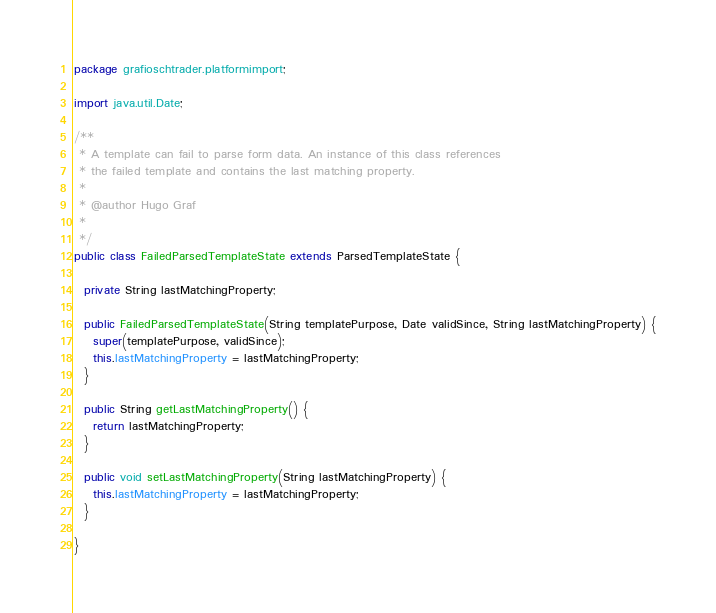<code> <loc_0><loc_0><loc_500><loc_500><_Java_>package grafioschtrader.platformimport;

import java.util.Date;

/**
 * A template can fail to parse form data. An instance of this class references
 * the failed template and contains the last matching property.
 *
 * @author Hugo Graf
 *
 */
public class FailedParsedTemplateState extends ParsedTemplateState {

  private String lastMatchingProperty;

  public FailedParsedTemplateState(String templatePurpose, Date validSince, String lastMatchingProperty) {
    super(templatePurpose, validSince);
    this.lastMatchingProperty = lastMatchingProperty;
  }

  public String getLastMatchingProperty() {
    return lastMatchingProperty;
  }

  public void setLastMatchingProperty(String lastMatchingProperty) {
    this.lastMatchingProperty = lastMatchingProperty;
  }

}
</code> 